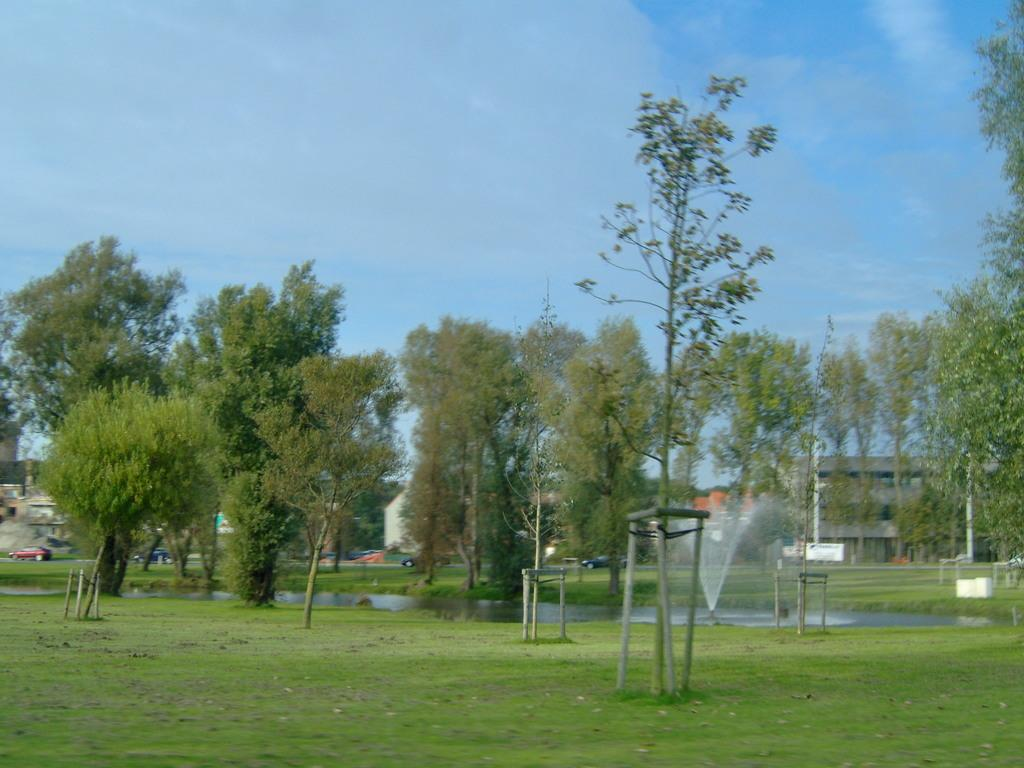What type of vegetation can be seen in the image? There are trees in the image. What is being used to water the vegetation? There are sprinklers in the image. What is the source of the water in the image? Water is visible in the image. What type of transportation is present in the image? Motor vehicles are present in the image. What type of structures can be seen in the image? There are buildings in the image. What is visible in the sky in the image? The sky is visible in the image, and there are clouds in the sky. Where is the coal mine located in the image? There is no coal mine present in the image. What type of field can be seen in the image? There is no field present in the image. Can you describe the ghostly apparition in the image? There is no ghostly apparition present in the image. 